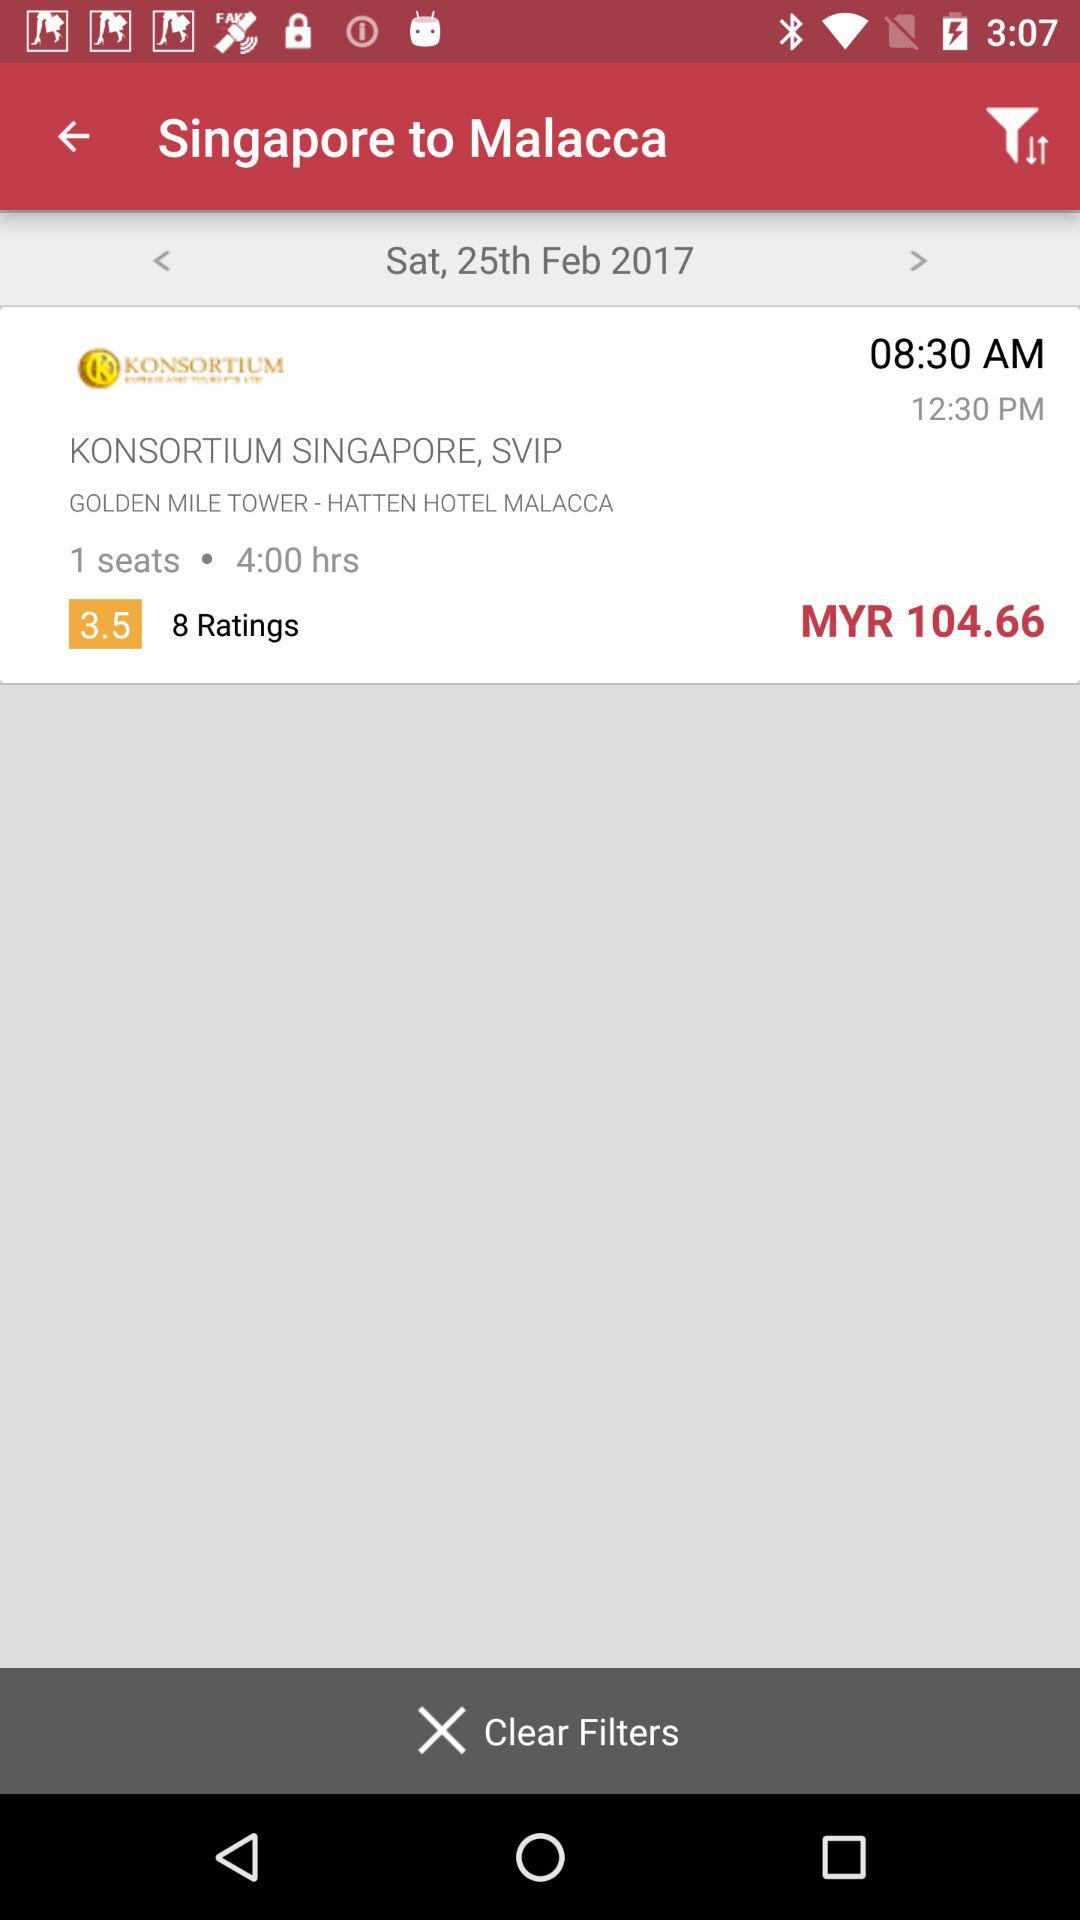How much is it per seat on Sunday, February 26, 2017?
When the provided information is insufficient, respond with <no answer>. <no answer> 